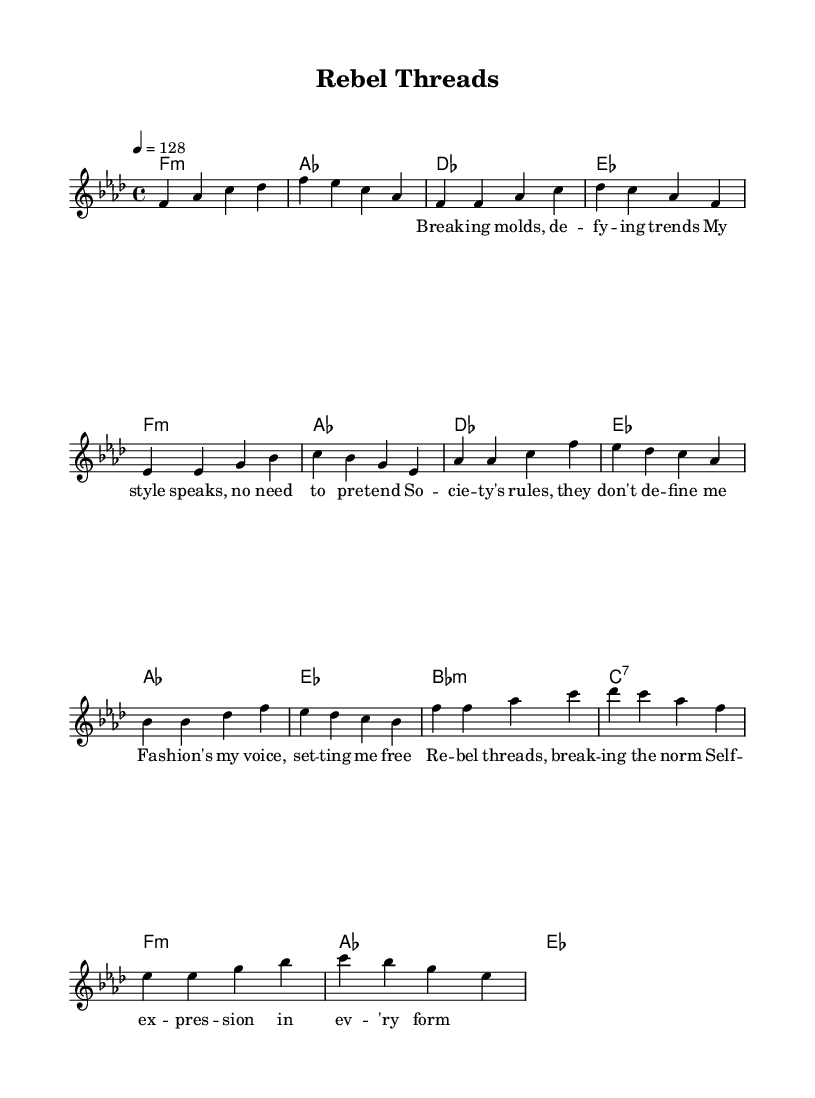What is the key signature of this music? The key signature is indicated at the beginning of the staff. It shows six flats, which corresponds to F minor.
Answer: F minor What is the time signature of this piece? The time signature is displayed at the beginning next to the key signature. It indicates the number of beats in each measure, shown as 4/4.
Answer: 4/4 What is the tempo marking for this piece? The tempo marking appears at the beginning of the score indicating the speed. It states to play at 128 beats per minute.
Answer: 128 How many measures are in the verse section? The verse section contains a total of four measures, indicated by vertical lines separating groups of four beats each.
Answer: 4 What is the primary theme expressed in the chorus lyrics? The chorus lyrics highlight themes of rebellion and self-expression, as indicated by phrases that emphasize breaking norms and expressing individuality through fashion.
Answer: Breaking the norm What chord follows the "Ees" chord in the pre-chorus? The chord progression shows that "Bes:m" follows the "Ees" chord, as observed in the harmonic section below the melody.
Answer: Bes minor What musical section immediately follows the pre-chorus? The structure of the song follows the pre-chorus with the chorus, as indicated by the lyrics and the chord changes that are characteristic of the song's flow.
Answer: Chorus 